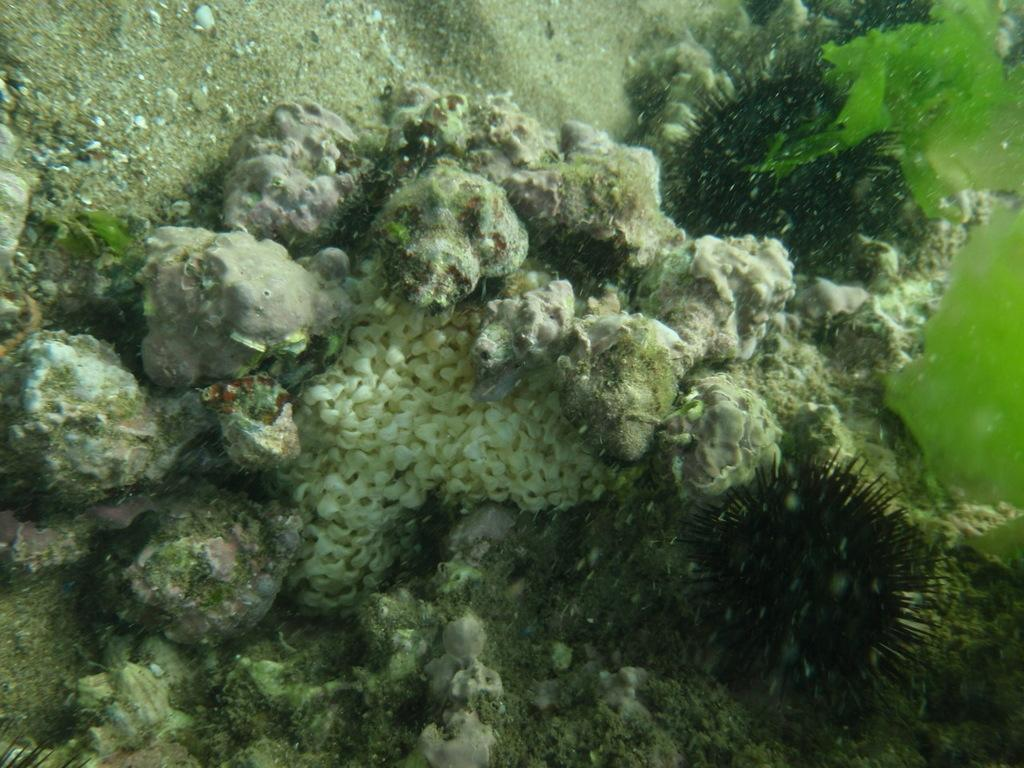What type of environment is shown in the image? The image depicts an underwater environment. What type of natural formation can be seen in the image? There are stones visible in the image. What other underwater feature is present in the image? There is a coral reef in the image. Can you see a pig swimming in the image? There is no pig visible in the image; it depicts an underwater environment with stones and a coral reef. What type of operation is being performed on the coral reef in the image? There is no operation being performed on the coral reef in the image; it is a natural underwater formation. 